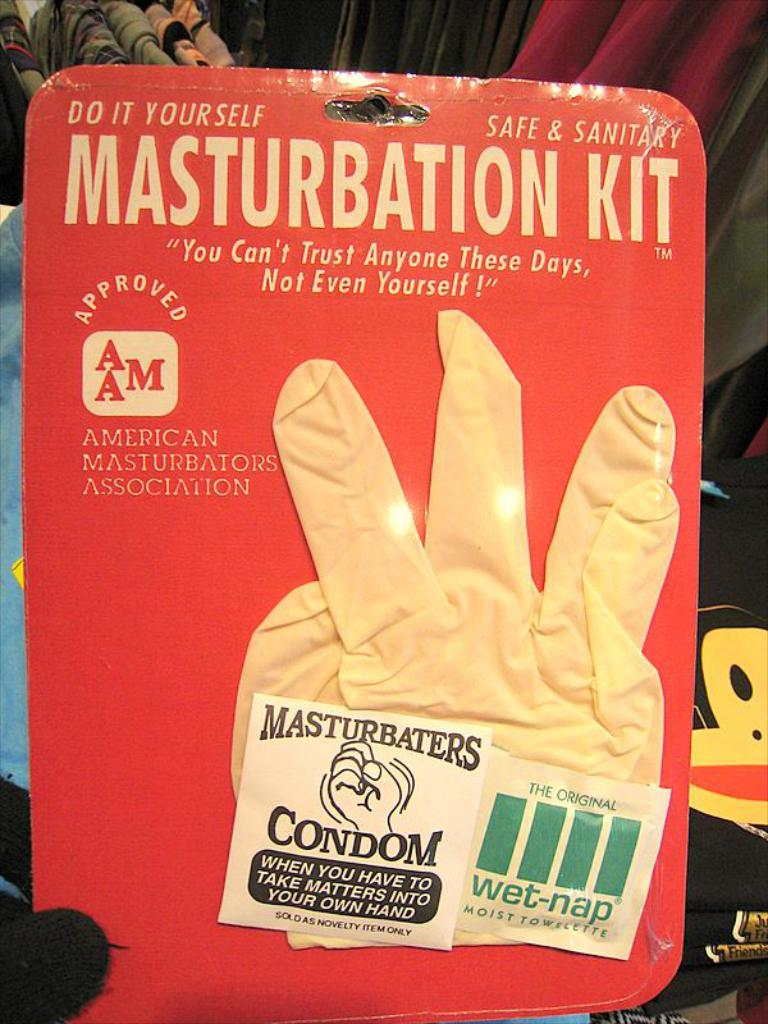<image>
Present a compact description of the photo's key features. A do it yourself masturbation kit including a glove and a wet nap. 